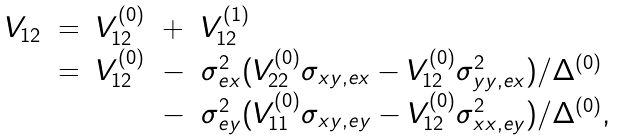<formula> <loc_0><loc_0><loc_500><loc_500>\begin{array} { c c c c l } V _ { 1 2 } & = & V _ { 1 2 } ^ { ( 0 ) } & + & V _ { 1 2 } ^ { ( 1 ) } \\ & = & V _ { 1 2 } ^ { ( 0 ) } & - & \sigma _ { e x } ^ { 2 } ( V _ { 2 2 } ^ { ( 0 ) } \sigma _ { x y , e x } - V _ { 1 2 } ^ { ( 0 ) } \sigma _ { y y , e x } ^ { 2 } ) / \Delta ^ { ( 0 ) } \\ & & & - & \sigma _ { e y } ^ { 2 } ( V _ { 1 1 } ^ { ( 0 ) } \sigma _ { x y , e y } - V _ { 1 2 } ^ { ( 0 ) } \sigma _ { x x , e y } ^ { 2 } ) / \Delta ^ { ( 0 ) } , \end{array}</formula> 